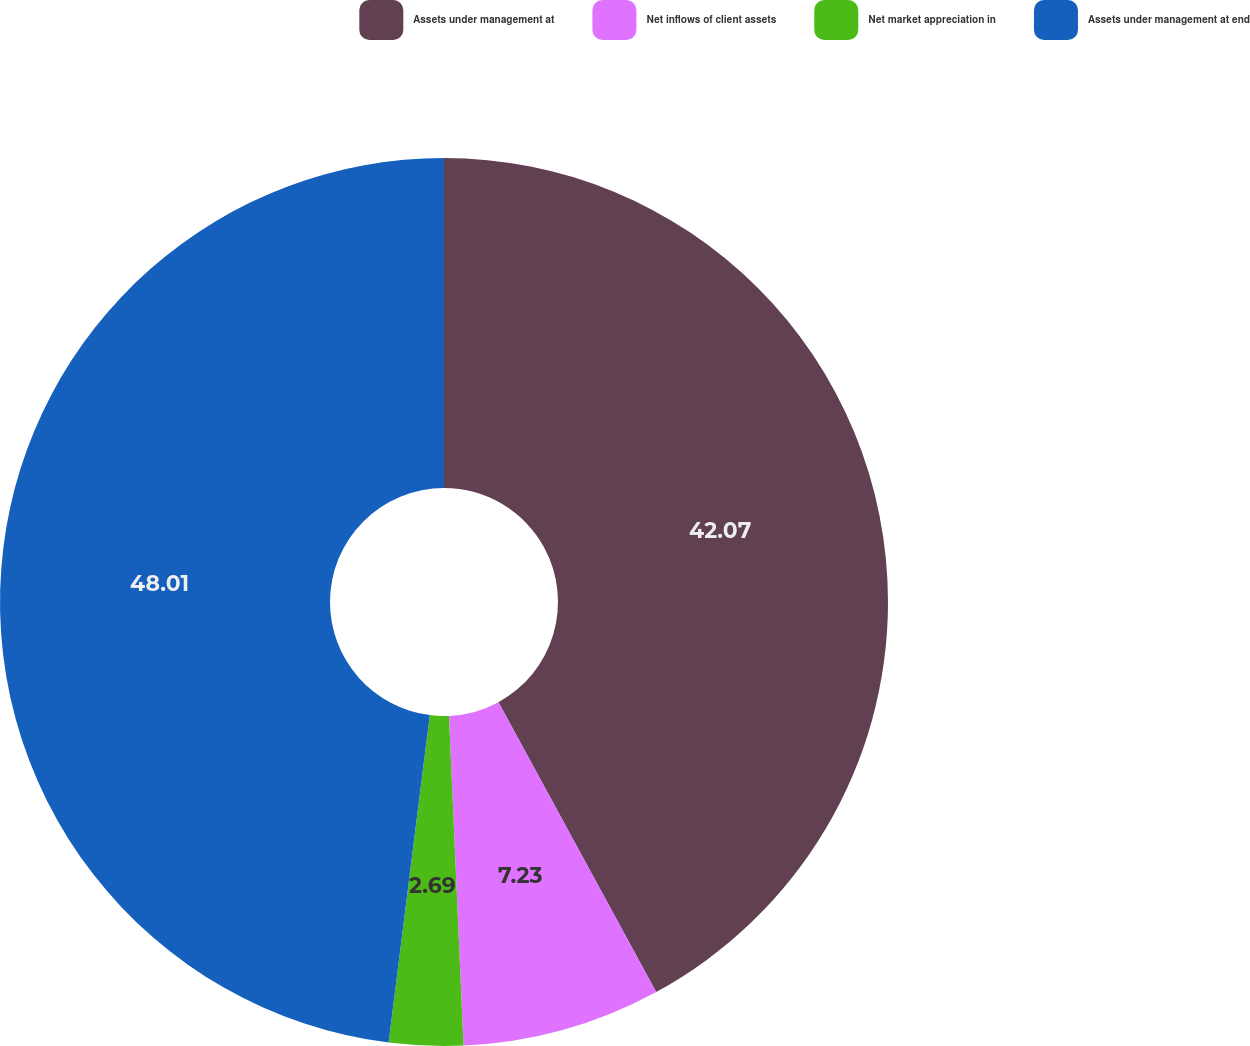Convert chart. <chart><loc_0><loc_0><loc_500><loc_500><pie_chart><fcel>Assets under management at<fcel>Net inflows of client assets<fcel>Net market appreciation in<fcel>Assets under management at end<nl><fcel>42.07%<fcel>7.23%<fcel>2.69%<fcel>48.01%<nl></chart> 